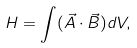<formula> <loc_0><loc_0><loc_500><loc_500>H = \int ( \vec { A } \cdot \vec { B } ) d V ,</formula> 